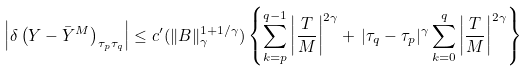Convert formula to latex. <formula><loc_0><loc_0><loc_500><loc_500>\left | \delta \left ( Y - \bar { Y } ^ { M } \right ) _ { \tau _ { p } \tau _ { q } } \right | \leq c ^ { \prime } ( \| B \| _ { \gamma } ^ { 1 + 1 / \gamma } ) \left \{ \sum _ { k = p } ^ { q - 1 } \left | \frac { T } { M } \right | ^ { 2 \gamma } + \, | \tau _ { q } - \tau _ { p } | ^ { \gamma } \sum _ { k = 0 } ^ { q } \left | \frac { T } { M } \right | ^ { 2 \gamma } \right \}</formula> 